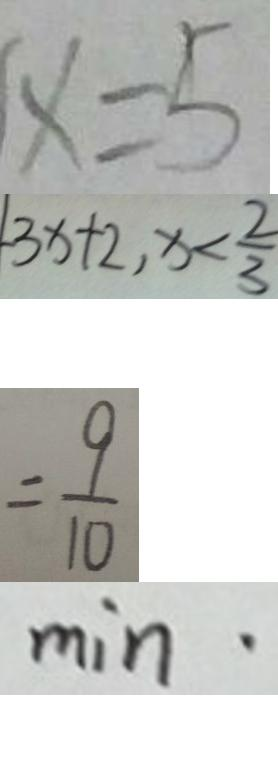Convert formula to latex. <formula><loc_0><loc_0><loc_500><loc_500>x = 5 
 - 3 x + 2 , x < \frac { 2 } { 3 } 
 = \frac { 9 } { 1 0 } 
 m i n \cdot</formula> 